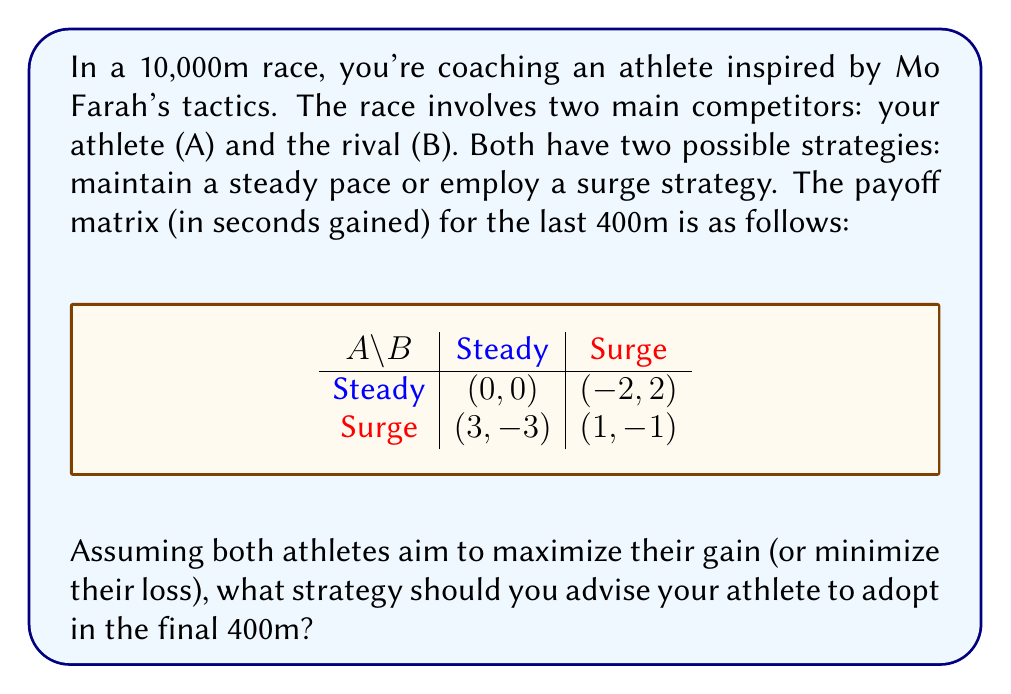Give your solution to this math problem. To solve this problem, we'll use the concept of Nash Equilibrium from game theory. Here's the step-by-step approach:

1) First, let's analyze the payoffs for Athlete A:
   - If B chooses Steady: A gains 0 with Steady, 3 with Surge
   - If B chooses Surge: A gains -2 with Steady, 1 with Surge

2) Now, let's find the best responses for A:
   - If B chooses Steady, A's best response is Surge (3 > 0)
   - If B chooses Surge, A's best response is Surge (1 > -2)

3) We can see that regardless of B's choice, A's best strategy is always to Surge. This is called a dominant strategy.

4) Let's verify if this is a Nash Equilibrium:
   - If A chooses Surge, B's best response is Steady (-3 > -1)
   - If B chooses Steady, A's best response is indeed Surge (3 > 0)

5) Therefore, (Surge, Steady) is a Nash Equilibrium, with payoffs (3, -3).

6) This equilibrium suggests that if both athletes play rationally:
   - Athlete A (your athlete) should employ the Surge strategy
   - Athlete B (the rival) should maintain a Steady pace

This strategy aligns well with Mo Farah's known tactic of maintaining pace and then surging in the final lap to outpace competitors who might be trying to conserve energy.
Answer: Advise athlete to Surge in final 400m 